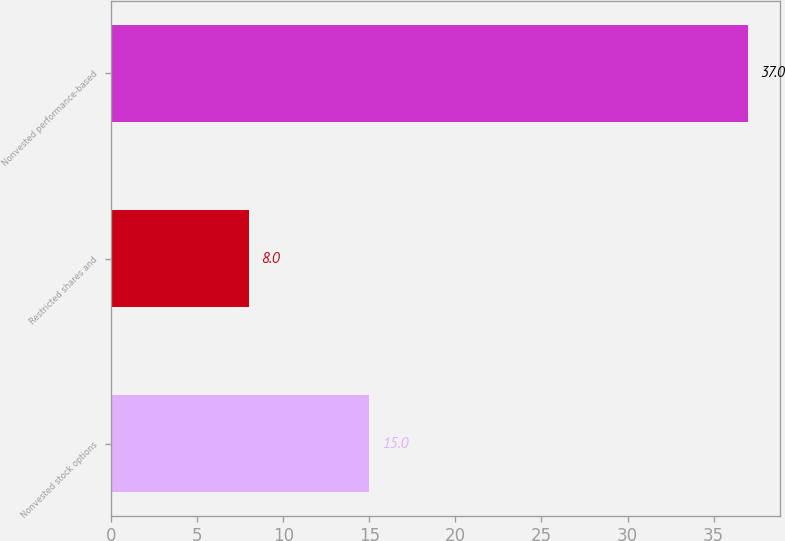Convert chart. <chart><loc_0><loc_0><loc_500><loc_500><bar_chart><fcel>Nonvested stock options<fcel>Restricted shares and<fcel>Nonvested performance-based<nl><fcel>15<fcel>8<fcel>37<nl></chart> 